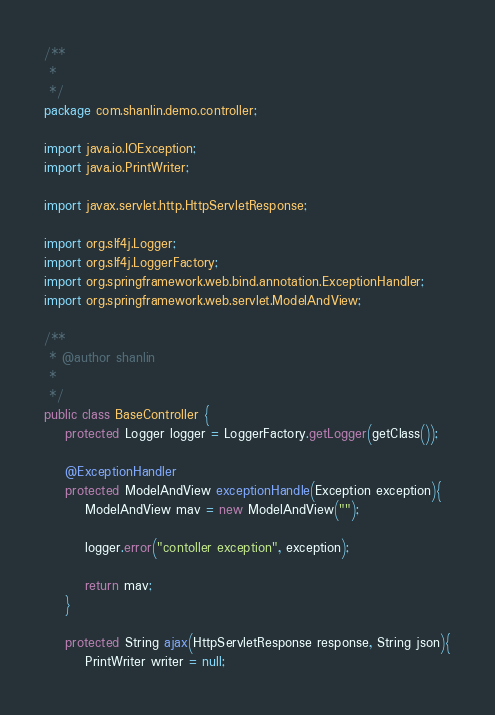Convert code to text. <code><loc_0><loc_0><loc_500><loc_500><_Java_>/**
 * 
 */
package com.shanlin.demo.controller;

import java.io.IOException;
import java.io.PrintWriter;

import javax.servlet.http.HttpServletResponse;

import org.slf4j.Logger;
import org.slf4j.LoggerFactory;
import org.springframework.web.bind.annotation.ExceptionHandler;
import org.springframework.web.servlet.ModelAndView;

/**
 * @author shanlin
 *
 */
public class BaseController {
	protected Logger logger = LoggerFactory.getLogger(getClass());
	
	@ExceptionHandler
	protected ModelAndView exceptionHandle(Exception exception){
		ModelAndView mav = new ModelAndView("");
		
		logger.error("contoller exception", exception);
		
		return mav;
	}
	
	protected String ajax(HttpServletResponse response, String json){
		PrintWriter writer = null;</code> 